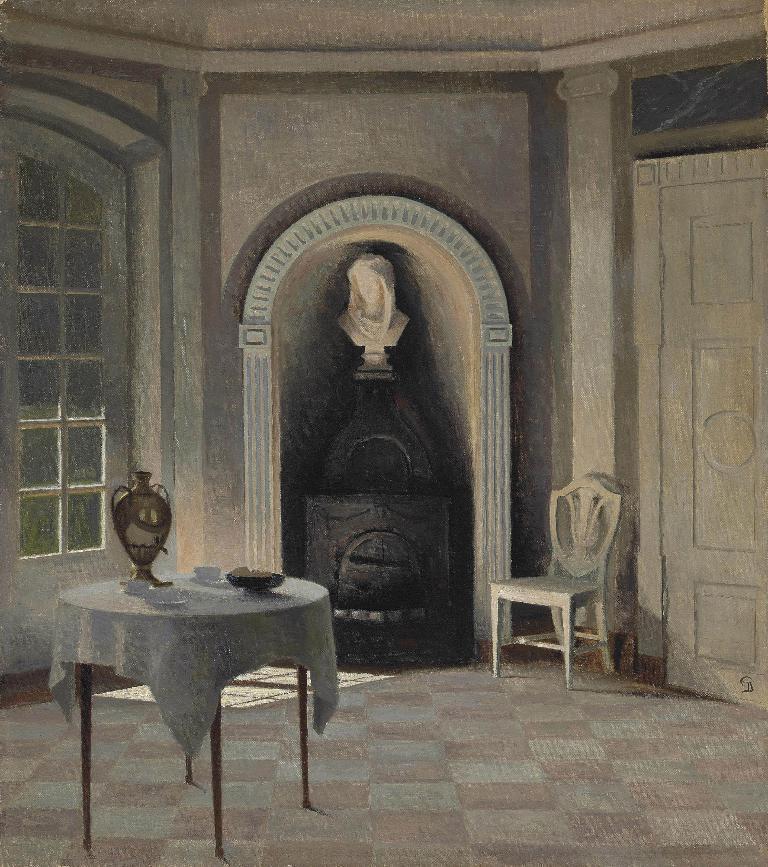Please provide a concise description of this image. It is some construction inside a room,there is a white sculpture and in front of that there is a chair and there is table and on the table there is teapot and two cups and a bowl all are kept. 